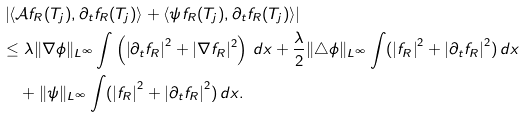<formula> <loc_0><loc_0><loc_500><loc_500>& \left | \langle \mathcal { A } f _ { R } ( T _ { j } ) , \partial _ { t } f _ { R } ( T _ { j } ) \rangle + \langle \psi f _ { R } ( T _ { j } ) , \partial _ { t } f _ { R } ( T _ { j } ) \rangle \right | \\ & \leq \lambda \| \nabla \phi \| _ { L ^ { \infty } } \int \left ( \left | \partial _ { t } f _ { R } \right | ^ { 2 } + | \nabla f _ { R } | ^ { 2 } \right ) \, d x + \frac { \lambda } { 2 } \| \triangle \phi \| _ { L ^ { \infty } } \int ( \left | f _ { R } \right | ^ { 2 } + \left | \partial _ { t } f _ { R } \right | ^ { 2 } ) \, d x \\ & \quad + \| \psi \| _ { L ^ { \infty } } \int ( \left | f _ { R } \right | ^ { 2 } + \left | \partial _ { t } f _ { R } \right | ^ { 2 } ) \, d x .</formula> 